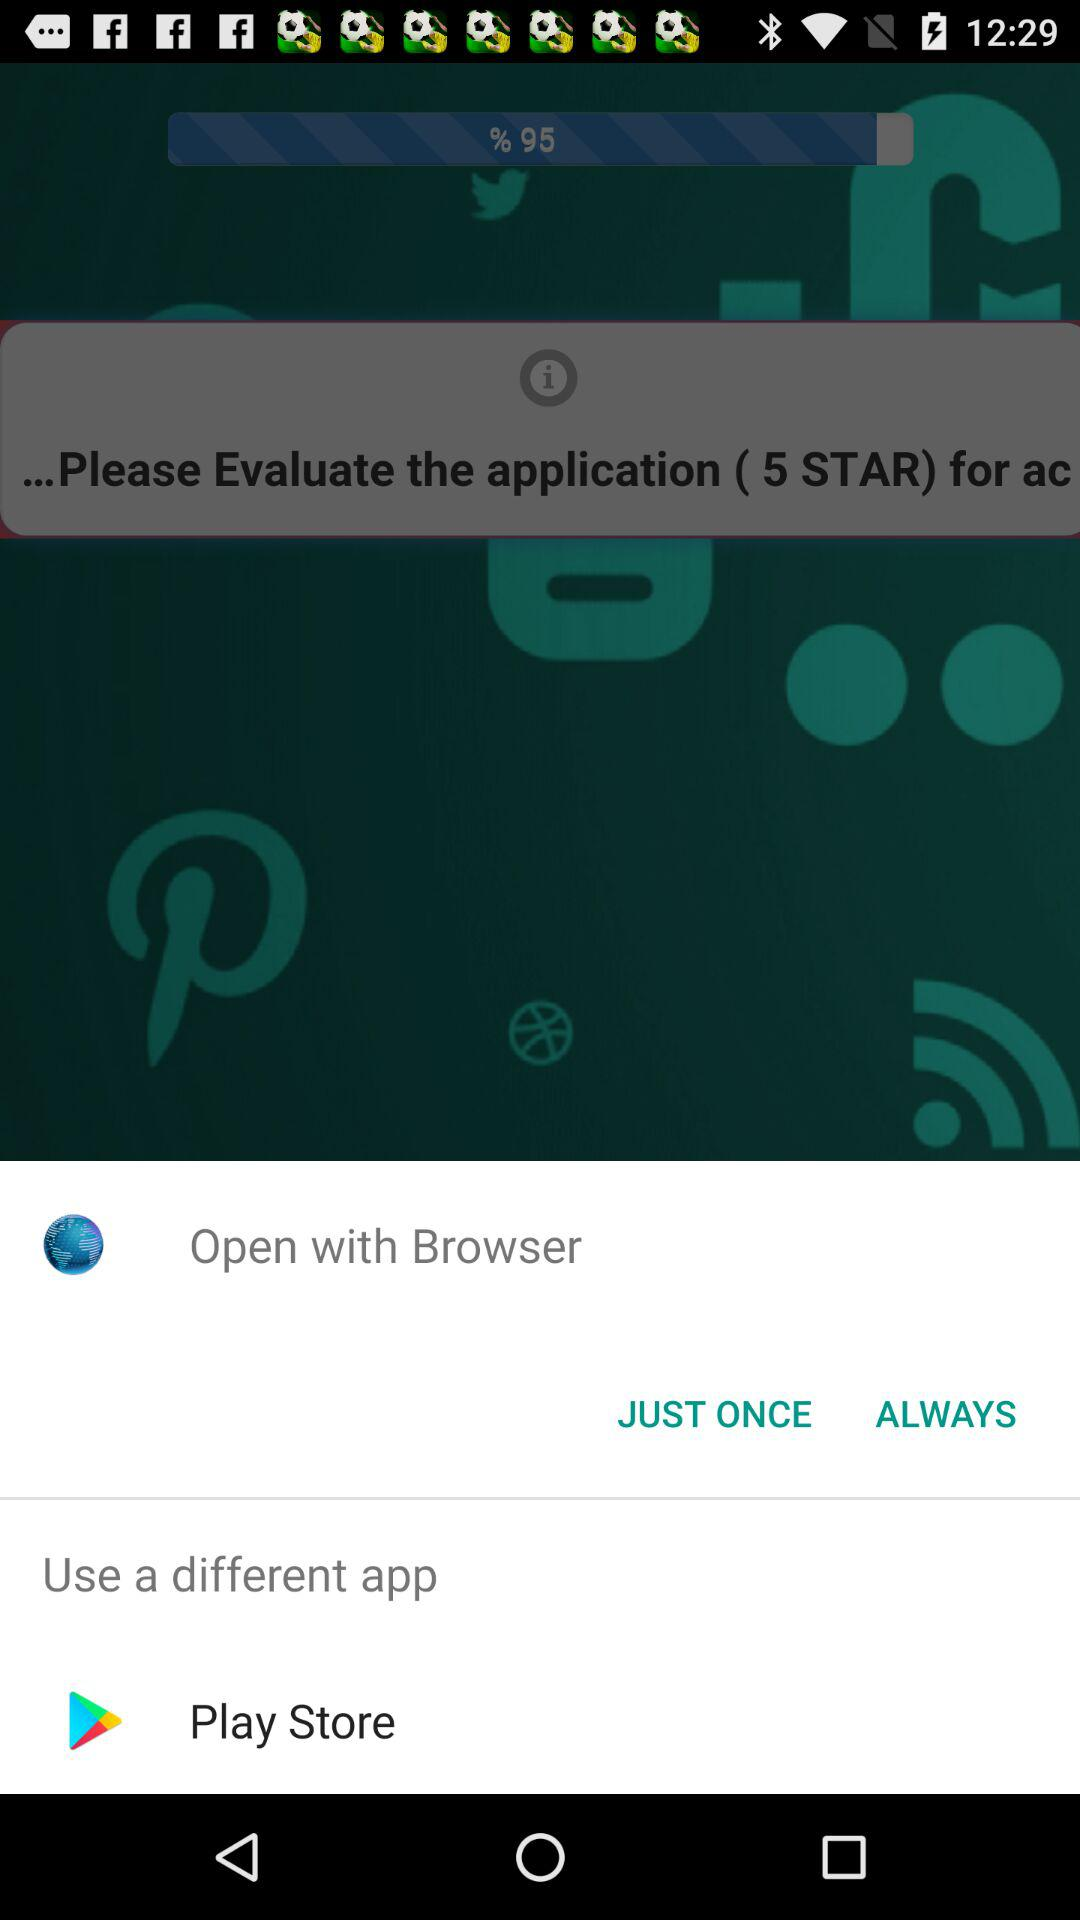Which browser can we use for open?
When the provided information is insufficient, respond with <no answer>. <no answer> 